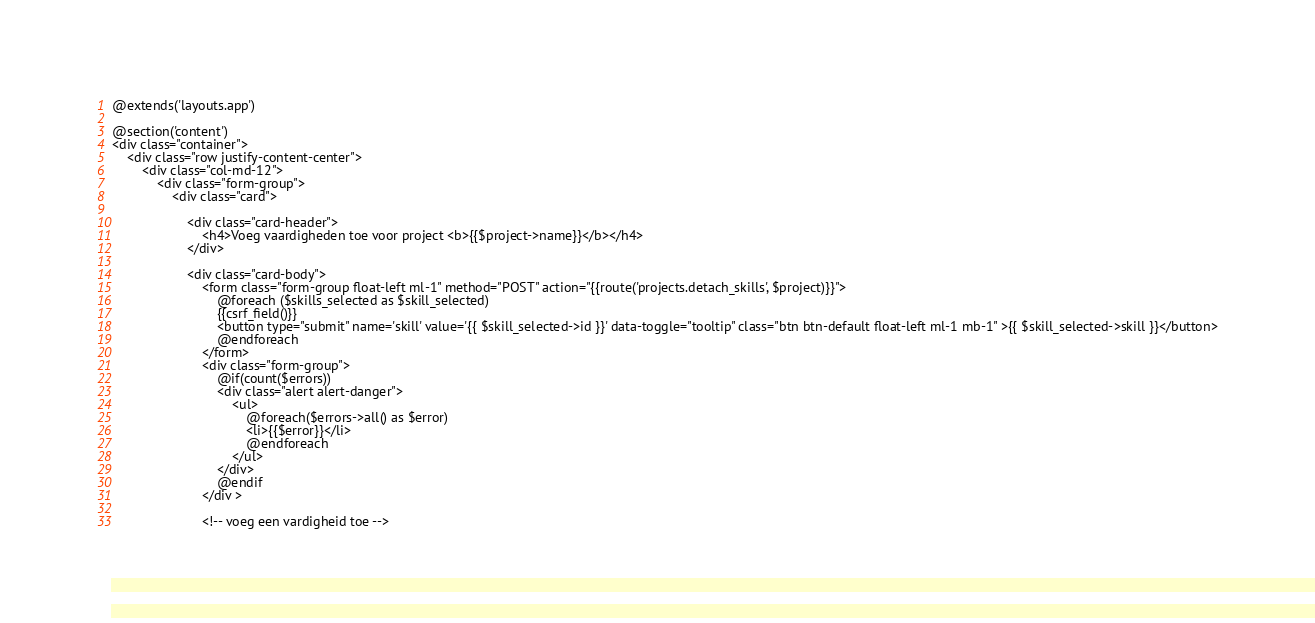Convert code to text. <code><loc_0><loc_0><loc_500><loc_500><_PHP_>@extends('layouts.app')

@section('content')
<div class="container">
    <div class="row justify-content-center">
        <div class="col-md-12">
            <div class="form-group">
                <div class="card">

                    <div class="card-header">  
                        <h4>Voeg vaardigheden toe voor project <b>{{$project->name}}</b></h4>
                    </div>

                    <div class="card-body">  
                        <form class="form-group float-left ml-1" method="POST" action="{{route('projects.detach_skills', $project)}}">
                            @foreach ($skills_selected as $skill_selected)
                            {{csrf_field()}}
                            <button type="submit" name='skill' value='{{ $skill_selected->id }}' data-toggle="tooltip" class="btn btn-default float-left ml-1 mb-1" >{{ $skill_selected->skill }}</button>
                            @endforeach
                        </form>
                        <div class="form-group">
                            @if(count($errors))
                            <div class="alert alert-danger">
                                <ul>
                                    @foreach($errors->all() as $error) 
                                    <li>{{$error}}</li>
                                    @endforeach
                                </ul>
                            </div>
                            @endif
                        </div >

                        <!-- voeg een vardigheid toe --></code> 